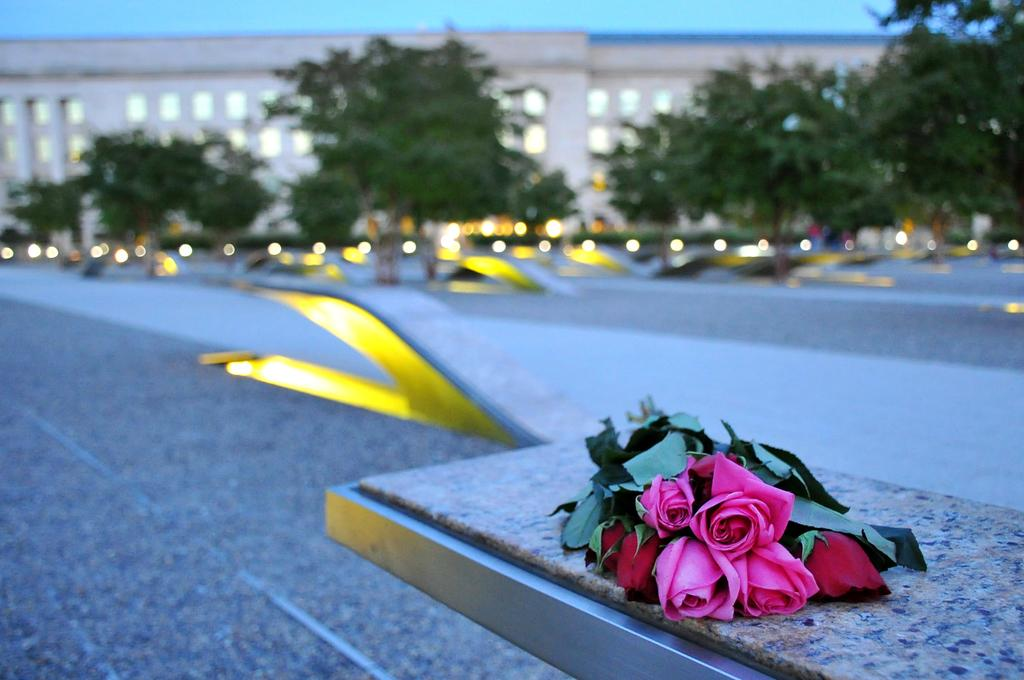What type of vegetation can be seen in the image? There are trees in the image. What type of structure is present in the image? There is a building in the image. What type of flowers are on the table in the image? There are rose flowers on a table in the image. What can be seen illuminating the scene in the image? There are lights visible in the image. How many corks are on the table with the rose flowers in the image? There is no mention of corks in the image; it features a table with rose flowers. What type of cover is protecting the kittens in the image? There are no kittens present in the image. 